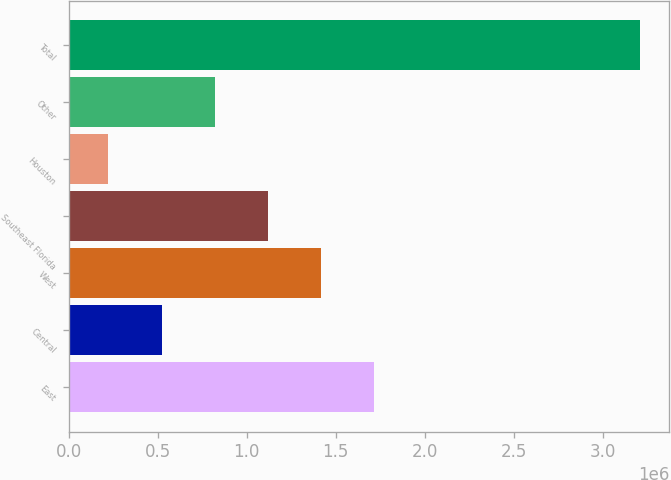Convert chart. <chart><loc_0><loc_0><loc_500><loc_500><bar_chart><fcel>East<fcel>Central<fcel>West<fcel>Southeast Florida<fcel>Houston<fcel>Other<fcel>Total<nl><fcel>1.71747e+06<fcel>521606<fcel>1.4185e+06<fcel>1.11954e+06<fcel>222641<fcel>820571<fcel>3.21229e+06<nl></chart> 